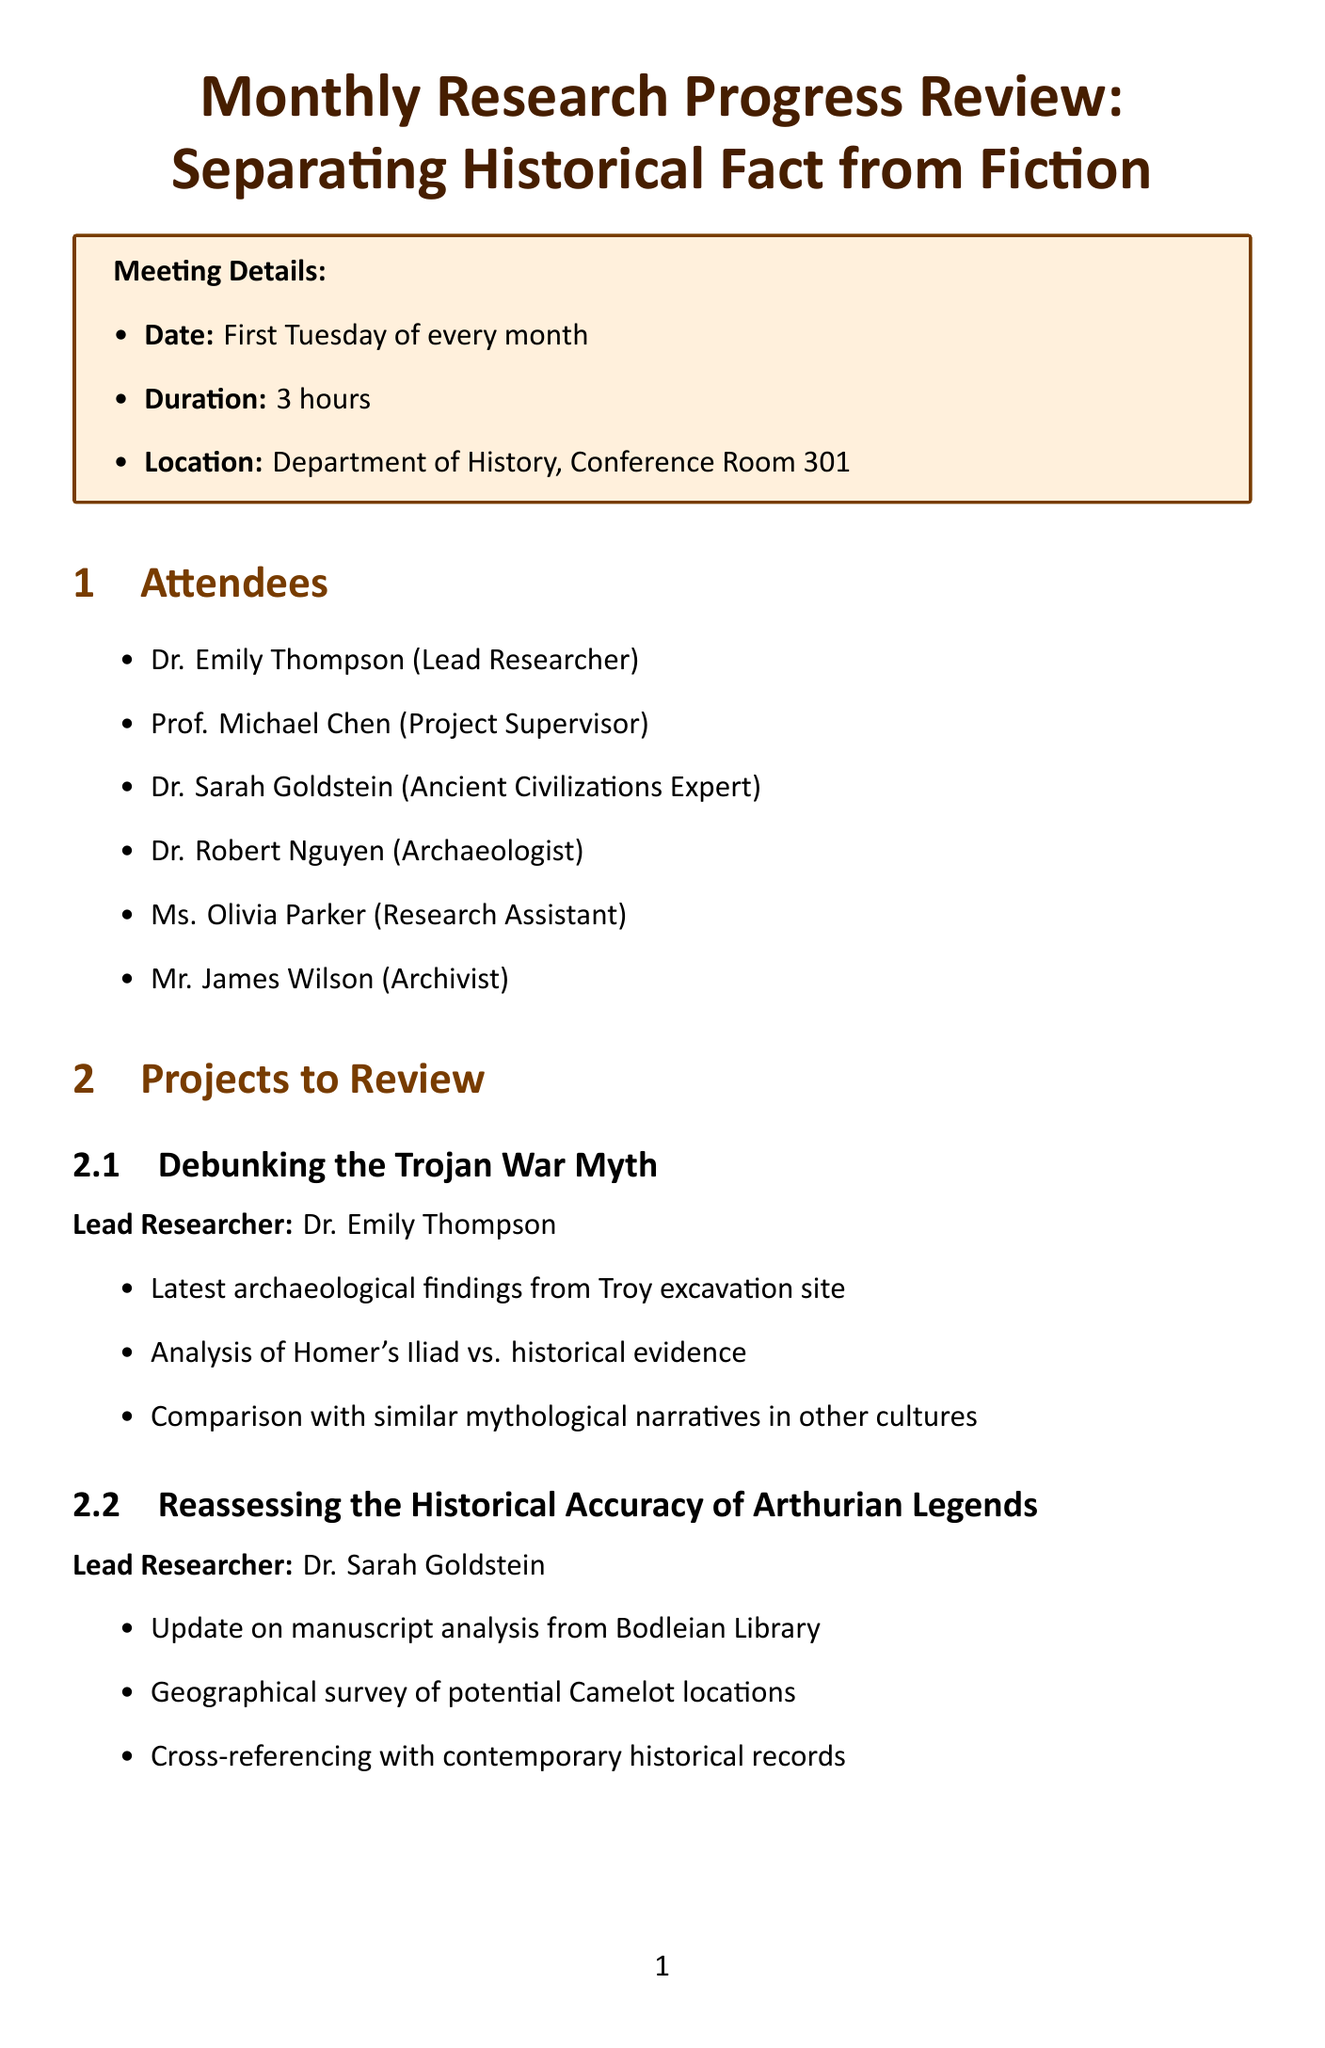What is the meeting title? The meeting title is stated at the top of the document.
Answer: Monthly Research Progress Review: Separating Historical Fact from Fiction When does the meeting occur? The recurring date is mentioned in the meeting details section.
Answer: First Tuesday of every month How long is the meeting scheduled for? The duration is specified in the meeting details section.
Answer: 3 hours What is the location of the meeting? The location is provided in the meeting details section.
Answer: Department of History, Conference Room 301 Who is the lead researcher for the project "Debunking the Trojan War Myth"? The lead researcher is listed directly under the project title in the document.
Answer: Dr. Emily Thompson What resources are needed for the meeting? The resources needed are outlined in a specific section of the document.
Answer: Projector for PowerPoint presentations What is one action item listed in the document? The action items are clearly listed in their own section.
Answer: Update project timelines based on new findings What is the topic of the guest speaker? The topic of the guest speaker is provided in the guest speaker section.
Answer: The Dangers of Mythological Interpretations in Modern Historical Research What is one of the presentation topics? The presentation topics are included in a separate section.
Answer: Methodologies for distinguishing between historical fact and mythological embellishment Who is the archaeologist in the attendees list? The attendees are specified in a section of the document with their titles.
Answer: Dr. Robert Nguyen 